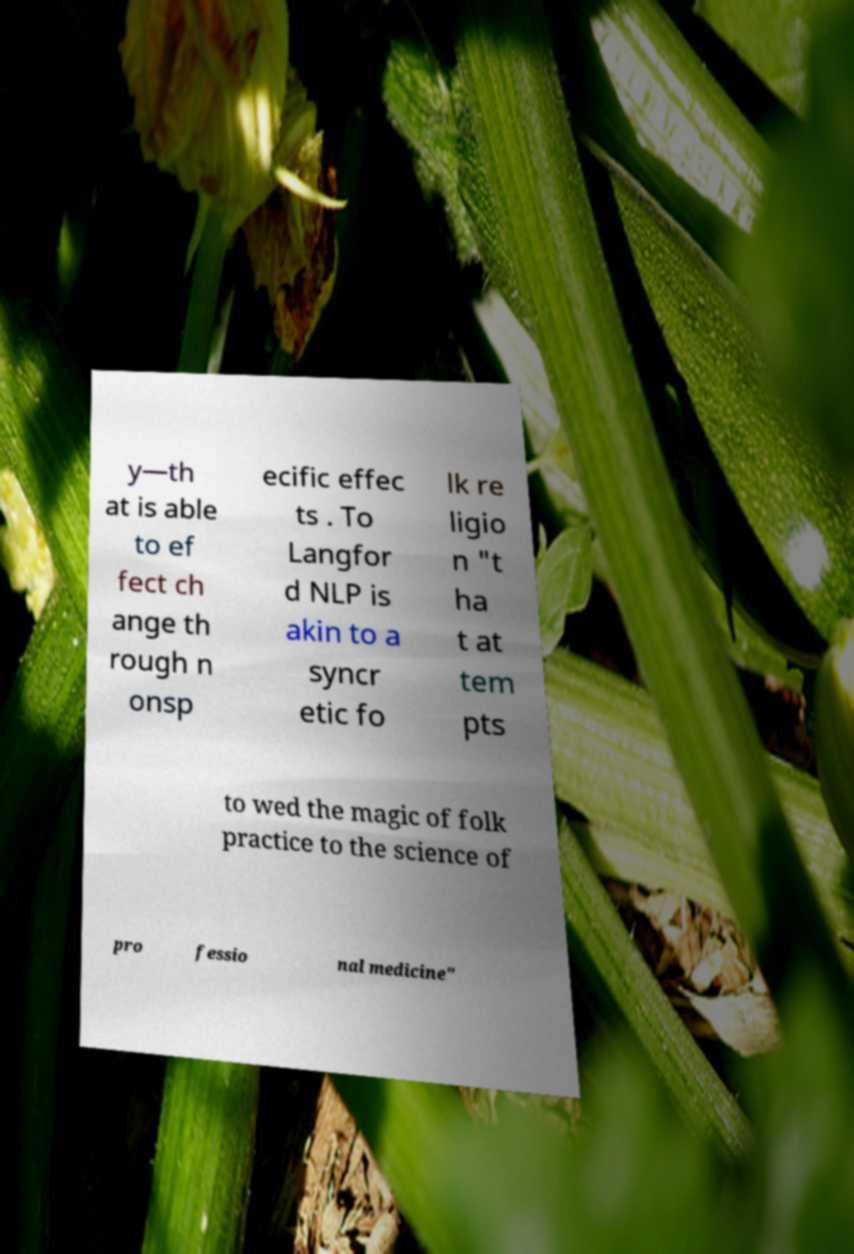I need the written content from this picture converted into text. Can you do that? y—th at is able to ef fect ch ange th rough n onsp ecific effec ts . To Langfor d NLP is akin to a syncr etic fo lk re ligio n "t ha t at tem pts to wed the magic of folk practice to the science of pro fessio nal medicine" 